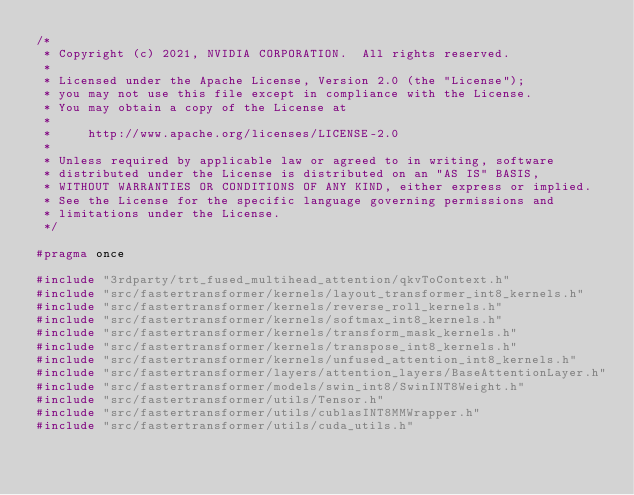<code> <loc_0><loc_0><loc_500><loc_500><_C_>/*
 * Copyright (c) 2021, NVIDIA CORPORATION.  All rights reserved.
 *
 * Licensed under the Apache License, Version 2.0 (the "License");
 * you may not use this file except in compliance with the License.
 * You may obtain a copy of the License at
 *
 *     http://www.apache.org/licenses/LICENSE-2.0
 *
 * Unless required by applicable law or agreed to in writing, software
 * distributed under the License is distributed on an "AS IS" BASIS,
 * WITHOUT WARRANTIES OR CONDITIONS OF ANY KIND, either express or implied.
 * See the License for the specific language governing permissions and
 * limitations under the License.
 */

#pragma once

#include "3rdparty/trt_fused_multihead_attention/qkvToContext.h"
#include "src/fastertransformer/kernels/layout_transformer_int8_kernels.h"
#include "src/fastertransformer/kernels/reverse_roll_kernels.h"
#include "src/fastertransformer/kernels/softmax_int8_kernels.h"
#include "src/fastertransformer/kernels/transform_mask_kernels.h"
#include "src/fastertransformer/kernels/transpose_int8_kernels.h"
#include "src/fastertransformer/kernels/unfused_attention_int8_kernels.h"
#include "src/fastertransformer/layers/attention_layers/BaseAttentionLayer.h"
#include "src/fastertransformer/models/swin_int8/SwinINT8Weight.h"
#include "src/fastertransformer/utils/Tensor.h"
#include "src/fastertransformer/utils/cublasINT8MMWrapper.h"
#include "src/fastertransformer/utils/cuda_utils.h"</code> 